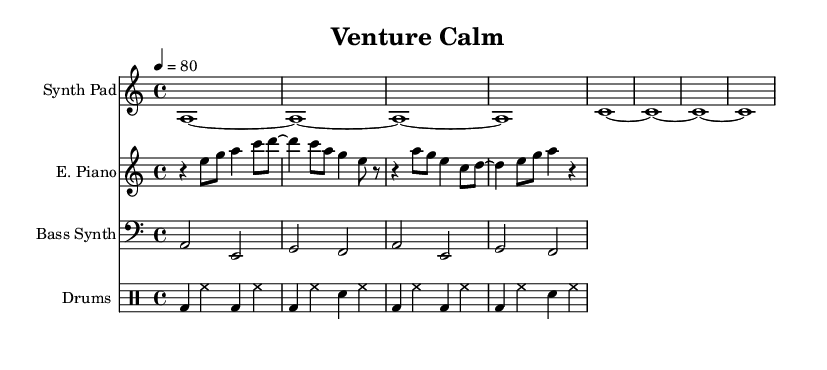What is the key signature of this music? The key signature indicates the key in which the music is written. In this case, the music is in A minor, which has no sharps or flats.
Answer: A minor What is the time signature of this music? The time signature is found at the beginning of the score. Here, it is written as 4/4, meaning there are four beats in each measure and a quarter note gets one beat.
Answer: 4/4 What is the tempo of this piece? The tempo marking indicates how fast the music should be played. The marking states 4 = 80, which means there are 80 quarter note beats per minute.
Answer: 80 How many measures are in the electric piano part? By counting the distinct groupings in the electric piano section, we find there are a total of four measures as indicated by the structure of the music notation.
Answer: 4 What type of synthesizer is utilized in the score? The score lists a "Bass Synth" as one of the instruments. This indicates a synthesizer sound typically used to provide bass tones in electronic music.
Answer: Bass Synth Which instrument plays the rhythmic foundation? The drum machine provides the rhythmic foundation of the piece, creating the ongoing beat that supports the other instruments.
Answer: Drum Machine What is the pattern of the bass synth notes? The bass synth plays a repetitive pattern alternating between the notes A and E, followed by G and F, establishing a foundational groove.
Answer: A, E, G, F 